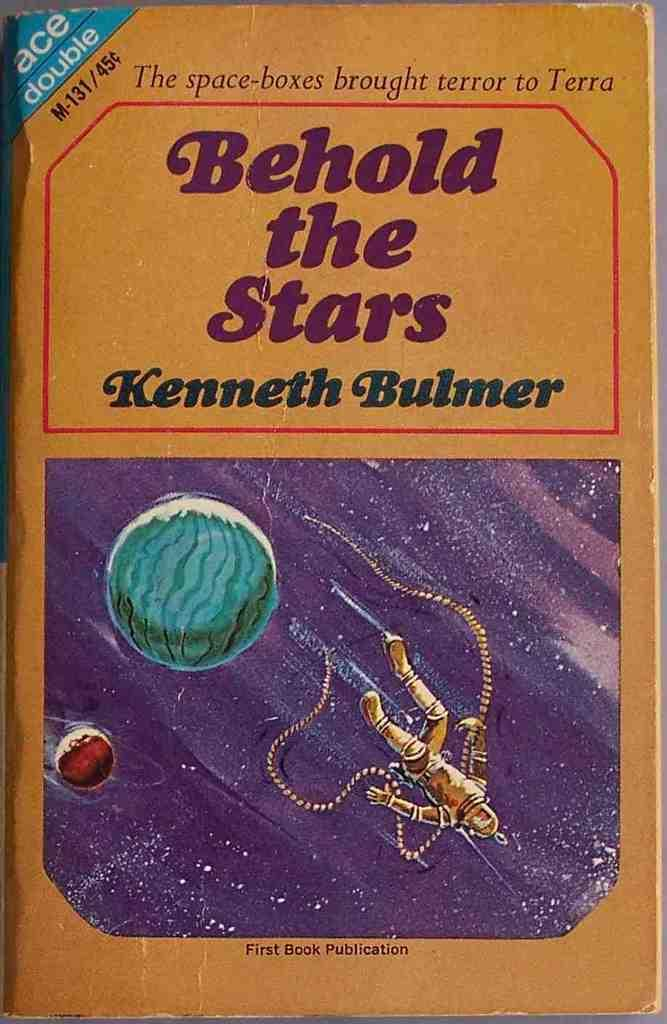<image>
Provide a brief description of the given image. A book written by Kenneth Bulmer is titled Behold the Stars. 